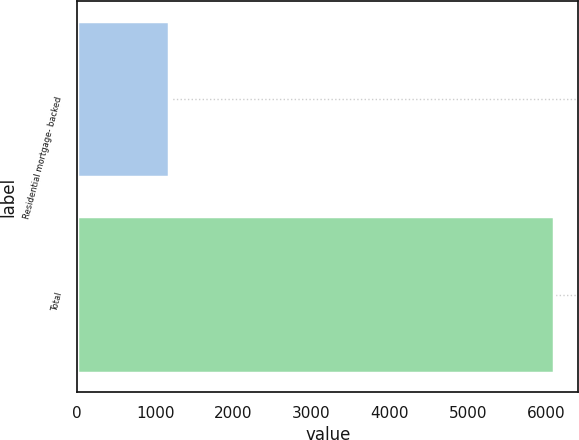<chart> <loc_0><loc_0><loc_500><loc_500><bar_chart><fcel>Residential mortgage- backed<fcel>Total<nl><fcel>1180<fcel>6109<nl></chart> 